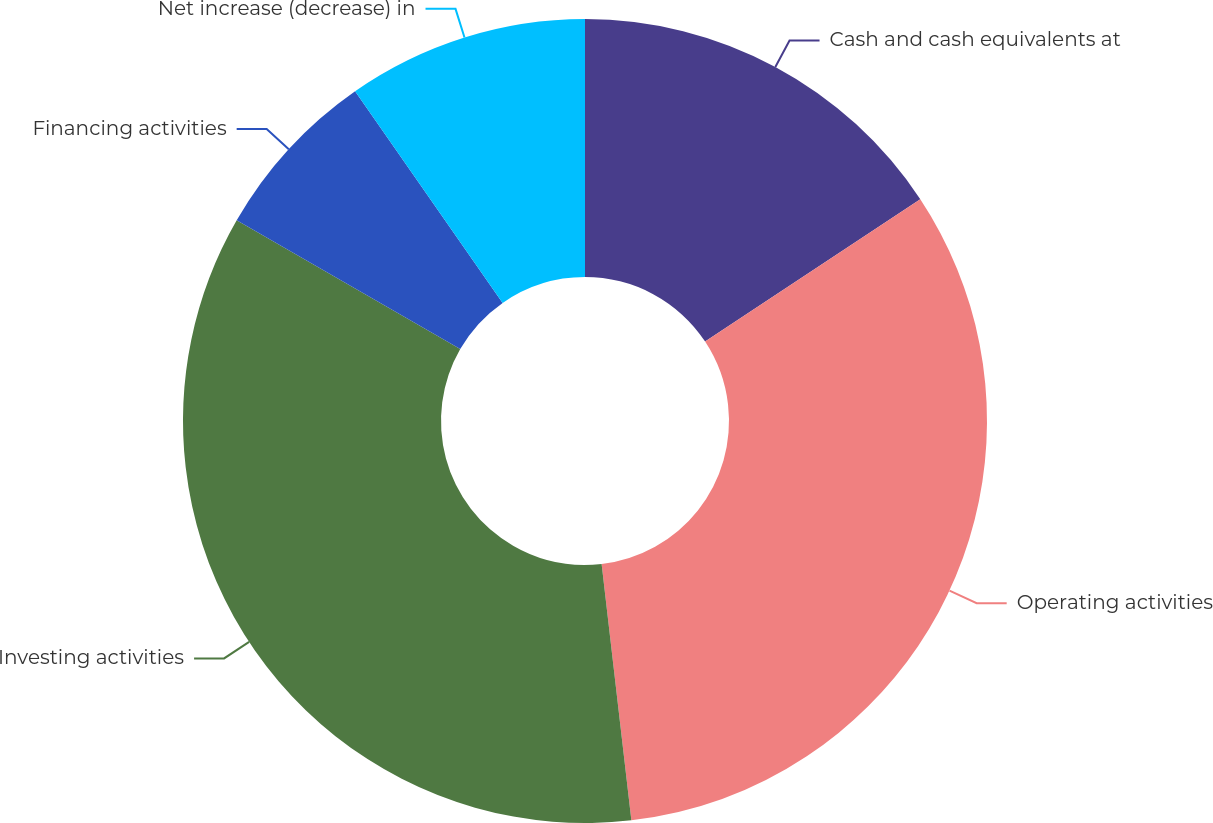Convert chart to OTSL. <chart><loc_0><loc_0><loc_500><loc_500><pie_chart><fcel>Cash and cash equivalents at<fcel>Operating activities<fcel>Investing activities<fcel>Financing activities<fcel>Net increase (decrease) in<nl><fcel>15.7%<fcel>32.46%<fcel>35.16%<fcel>6.99%<fcel>9.69%<nl></chart> 